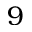Convert formula to latex. <formula><loc_0><loc_0><loc_500><loc_500>9</formula> 